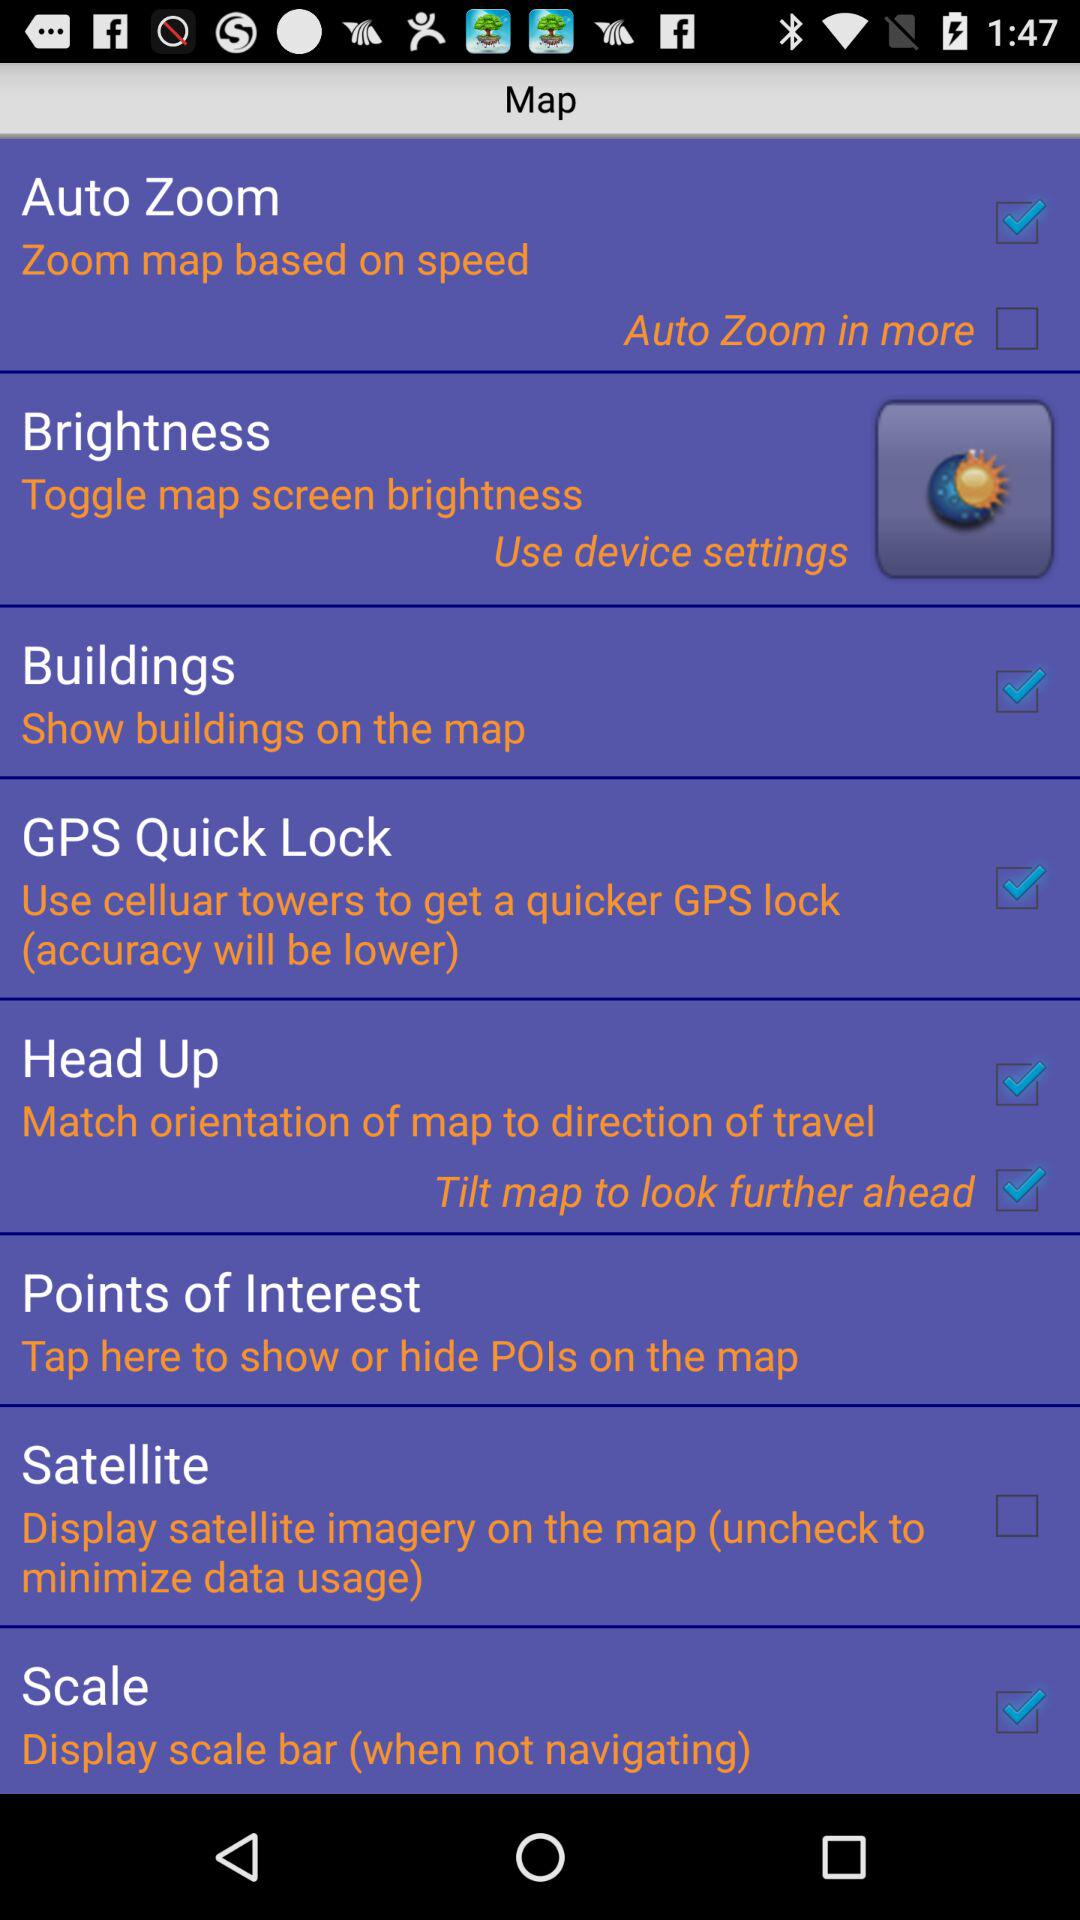What is the status of auto zoom? The status of auto zoom is on. 